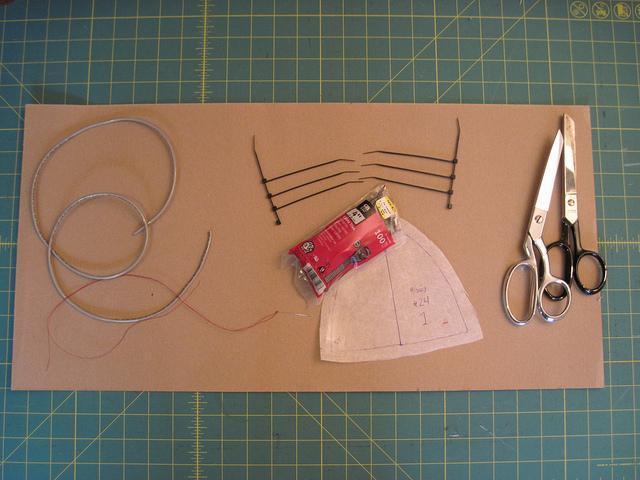How many scissors are on the board?
Give a very brief answer. 2. How many scissors are in the picture?
Give a very brief answer. 2. 